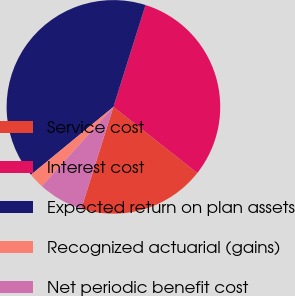Convert chart to OTSL. <chart><loc_0><loc_0><loc_500><loc_500><pie_chart><fcel>Service cost<fcel>Interest cost<fcel>Expected return on plan assets<fcel>Recognized actuarial (gains)<fcel>Net periodic benefit cost<nl><fcel>19.24%<fcel>30.76%<fcel>40.82%<fcel>2.35%<fcel>6.82%<nl></chart> 